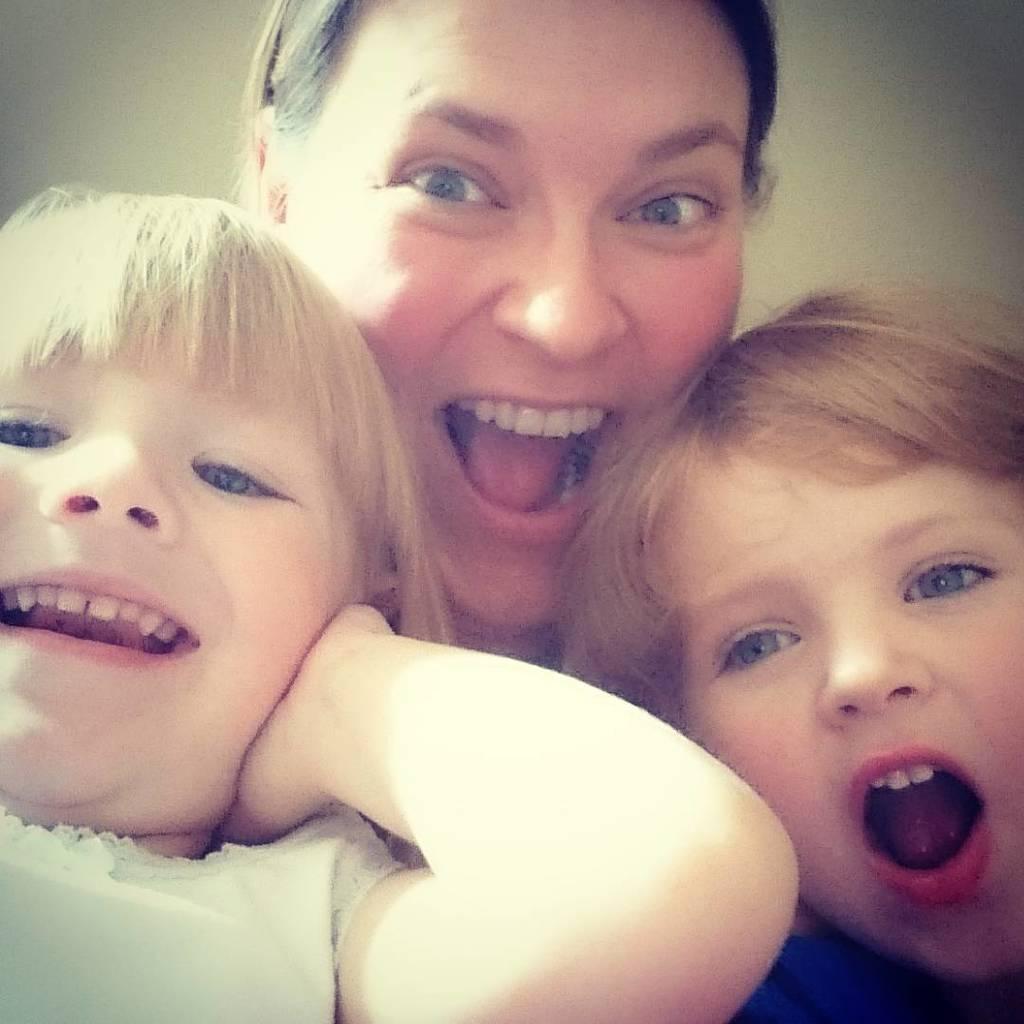Please provide a concise description of this image. This image consists of three persons. A woman and two children. It looks like it is clicked in a room. In the background, there is a wall. 